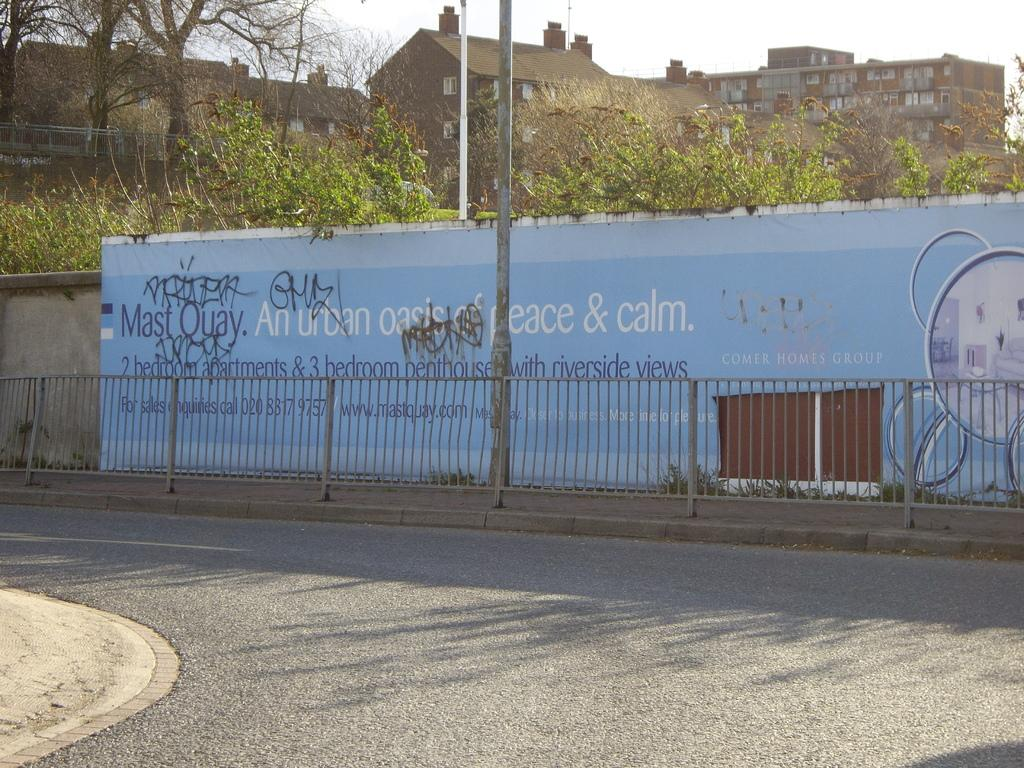What type of structures can be seen in the image? There are buildings in the image. What architectural features are visible on the buildings? There are windows visible on the buildings. What type of vegetation is present in the image? There are trees in the image. What other objects can be seen in the image? There are poles and fencing in the image. What is the color of the board in the image? The board in the image is blue. What is the color of the sky in the image? The sky appears to be white in color. What type of vest is being worn by the tree in the image? There are no vests present in the image, as trees do not wear clothing. What activity is taking place in the image involving a knot? There is no activity involving a knot present in the image. 